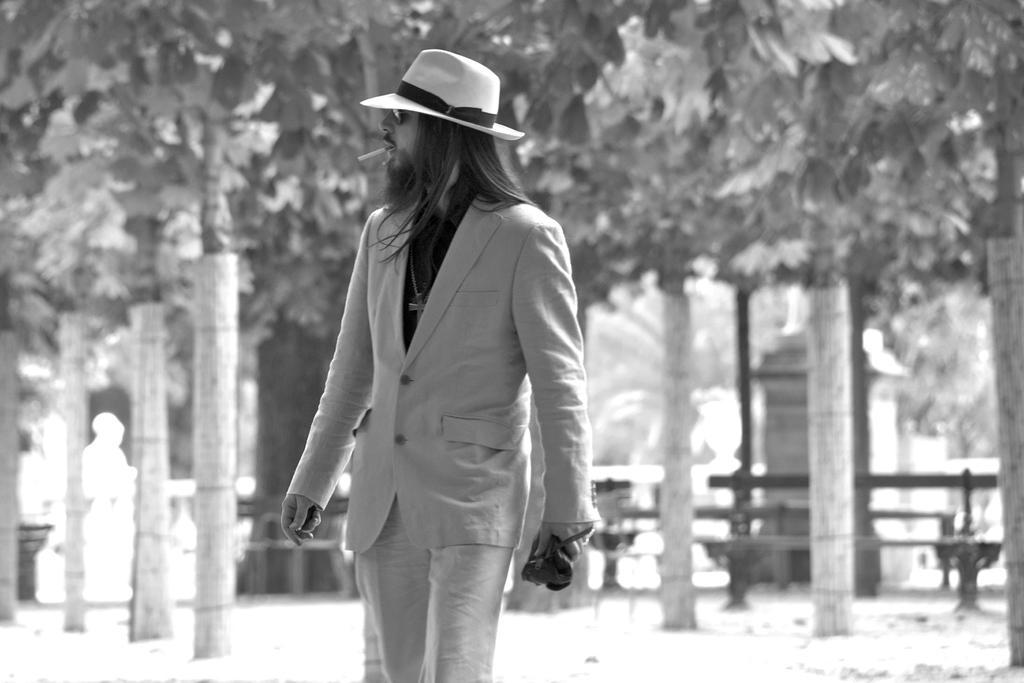Could you give a brief overview of what you see in this image? This is a black and white pic. We can see a man is standing and holding an object in his hand, cigarette in his mouth and hat on his head. In the background the image is blur but we can see trees and objects. 